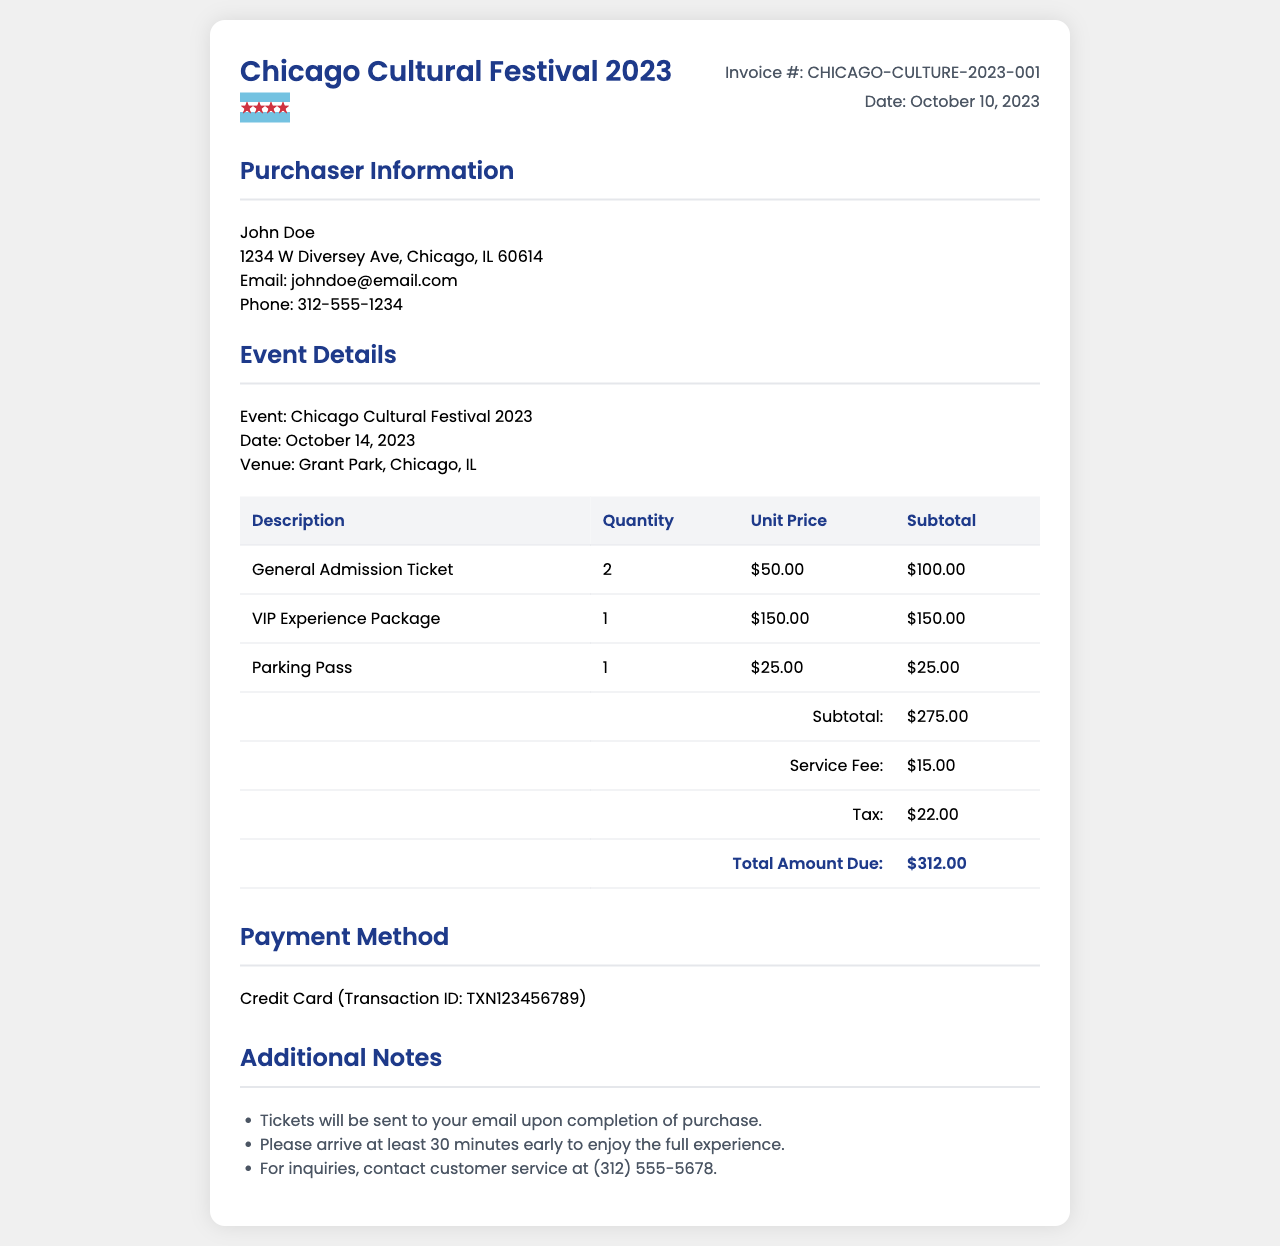What is the purchaser's name? The purchaser's name is listed at the top of the invoice under "Purchaser Information."
Answer: John Doe What is the event date? The event date is mentioned in the "Event Details" section of the invoice.
Answer: October 14, 2023 How many general admission tickets were purchased? The quantity of general admission tickets is shown in the table under "Quantity" for the respective ticket type.
Answer: 2 What is the subtotal amount before fees and taxes? The subtotal is a line item in the invoice that sums up the ticket prices before additional charges.
Answer: $275.00 What is the total amount due? The total amount due is the final sum calculated after factors like service fee and tax, shown at the bottom of the invoice table.
Answer: $312.00 What payment method was used? The payment method is outlined in the "Payment Method" section of the invoice.
Answer: Credit Card How much was the service fee? The service fee is listed as a separate line item in the invoice table.
Answer: $15.00 What is the transaction ID for the payment? The transaction ID is provided in the "Payment Method" section and is a specific identifier for the credit card transaction.
Answer: TXN123456789 What should you do before arriving at the event? The additional notes section mentions specific advice for attendees before arriving at the event.
Answer: Arrive at least 30 minutes early 